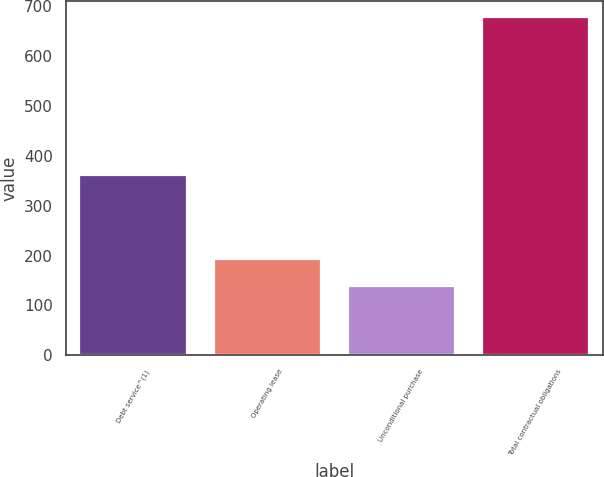Convert chart. <chart><loc_0><loc_0><loc_500><loc_500><bar_chart><fcel>Debt service^(1)<fcel>Operating lease<fcel>Unconditional purchase<fcel>Total contractual obligations<nl><fcel>361.3<fcel>192.88<fcel>139.1<fcel>676.9<nl></chart> 